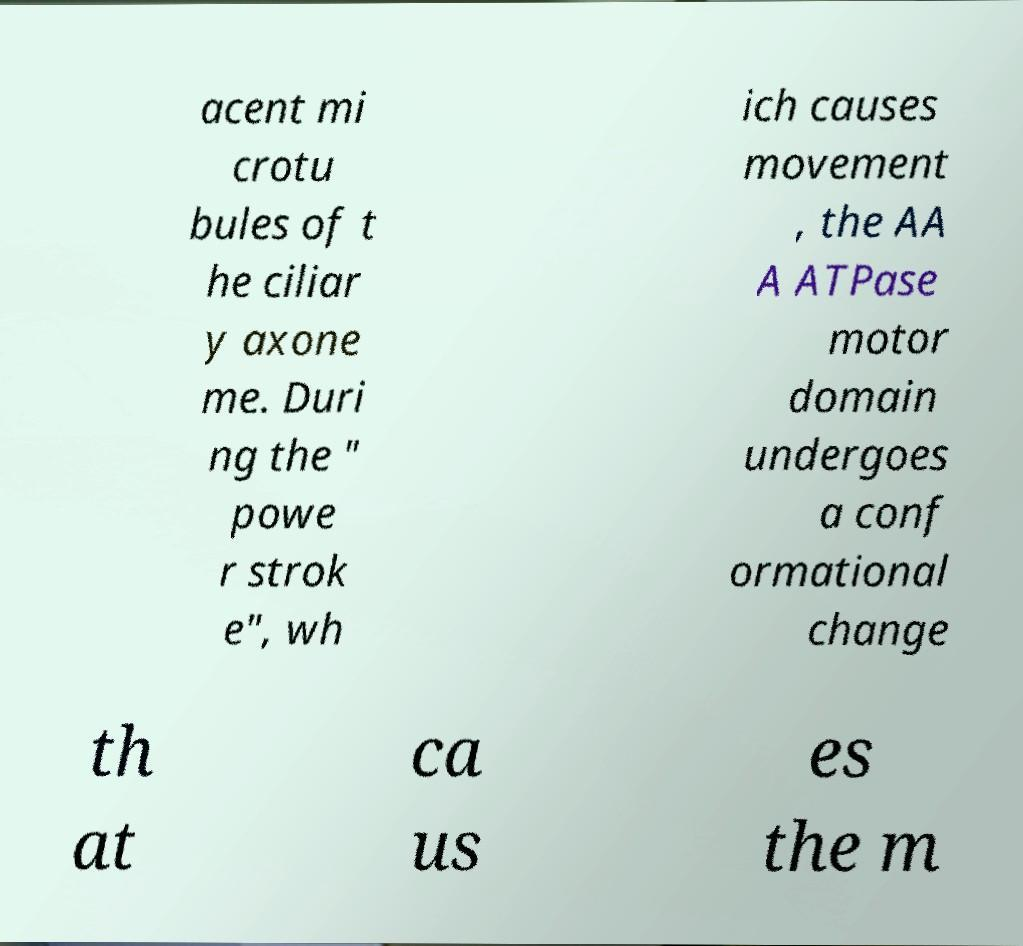Could you extract and type out the text from this image? acent mi crotu bules of t he ciliar y axone me. Duri ng the " powe r strok e", wh ich causes movement , the AA A ATPase motor domain undergoes a conf ormational change th at ca us es the m 